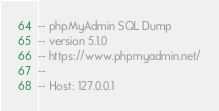Convert code to text. <code><loc_0><loc_0><loc_500><loc_500><_SQL_>-- phpMyAdmin SQL Dump
-- version 5.1.0
-- https://www.phpmyadmin.net/
--
-- Host: 127.0.0.1</code> 